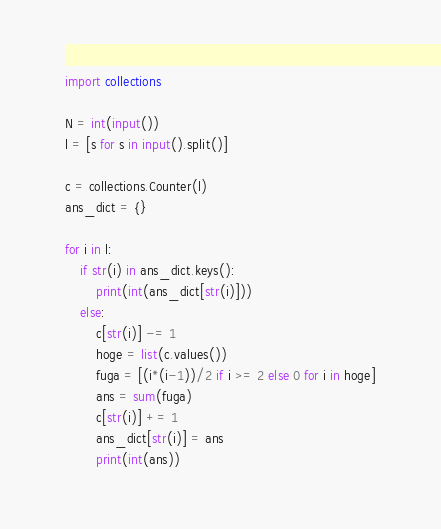<code> <loc_0><loc_0><loc_500><loc_500><_Python_>import collections

N = int(input())
l = [s for s in input().split()]

c = collections.Counter(l)
ans_dict = {}

for i in l:
    if str(i) in ans_dict.keys():
        print(int(ans_dict[str(i)]))
    else:
        c[str(i)] -= 1
        hoge = list(c.values())
        fuga = [(i*(i-1))/2 if i >= 2 else 0 for i in hoge]
        ans = sum(fuga)
        c[str(i)] += 1
        ans_dict[str(i)] = ans
        print(int(ans))</code> 